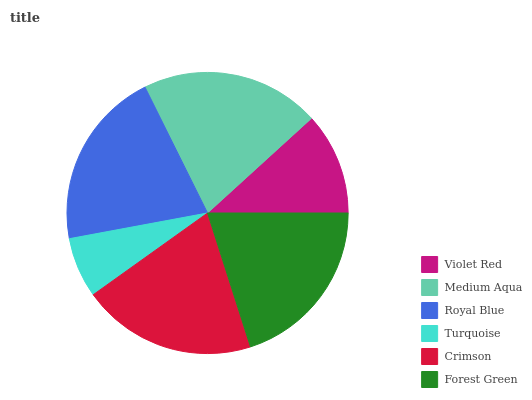Is Turquoise the minimum?
Answer yes or no. Yes. Is Royal Blue the maximum?
Answer yes or no. Yes. Is Medium Aqua the minimum?
Answer yes or no. No. Is Medium Aqua the maximum?
Answer yes or no. No. Is Medium Aqua greater than Violet Red?
Answer yes or no. Yes. Is Violet Red less than Medium Aqua?
Answer yes or no. Yes. Is Violet Red greater than Medium Aqua?
Answer yes or no. No. Is Medium Aqua less than Violet Red?
Answer yes or no. No. Is Forest Green the high median?
Answer yes or no. Yes. Is Crimson the low median?
Answer yes or no. Yes. Is Medium Aqua the high median?
Answer yes or no. No. Is Turquoise the low median?
Answer yes or no. No. 